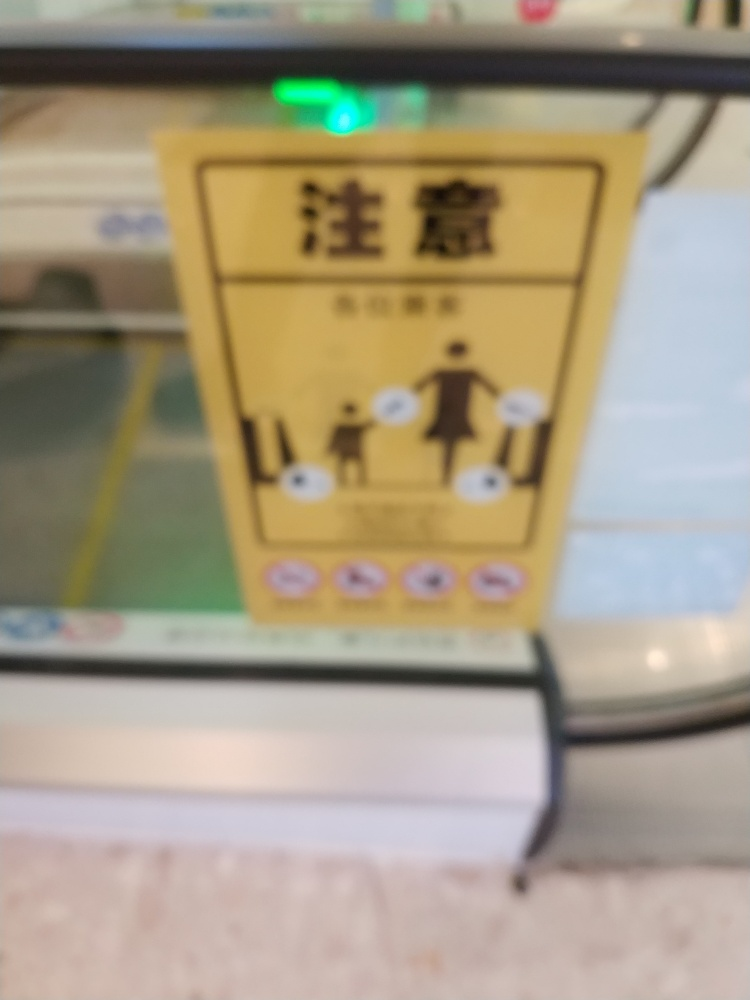Is the image in focus? The image is not in focus. The elements are blurred making it difficult to discern precise details like text or images. For optimal clarity, a photo should be sharp, with clear details that are easily distinguishable. 